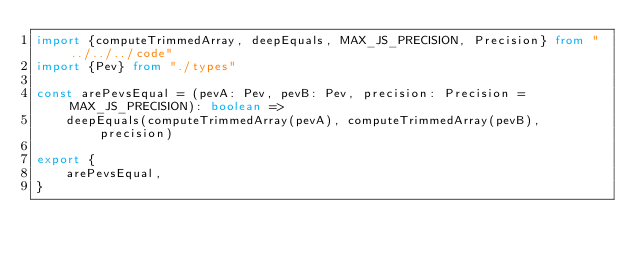<code> <loc_0><loc_0><loc_500><loc_500><_TypeScript_>import {computeTrimmedArray, deepEquals, MAX_JS_PRECISION, Precision} from "../../../code"
import {Pev} from "./types"

const arePevsEqual = (pevA: Pev, pevB: Pev, precision: Precision = MAX_JS_PRECISION): boolean =>
    deepEquals(computeTrimmedArray(pevA), computeTrimmedArray(pevB), precision)

export {
    arePevsEqual,
}
</code> 